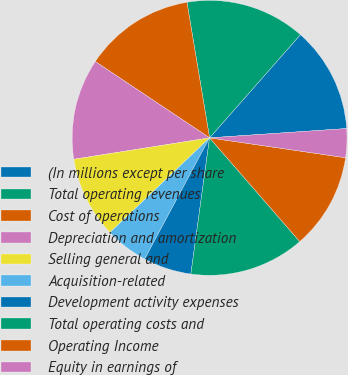<chart> <loc_0><loc_0><loc_500><loc_500><pie_chart><fcel>(In millions except per share<fcel>Total operating revenues<fcel>Cost of operations<fcel>Depreciation and amortization<fcel>Selling general and<fcel>Acquisition-related<fcel>Development activity expenses<fcel>Total operating costs and<fcel>Operating Income<fcel>Equity in earnings of<nl><fcel>12.43%<fcel>14.12%<fcel>12.99%<fcel>11.86%<fcel>9.6%<fcel>5.08%<fcel>5.65%<fcel>13.56%<fcel>11.3%<fcel>3.39%<nl></chart> 